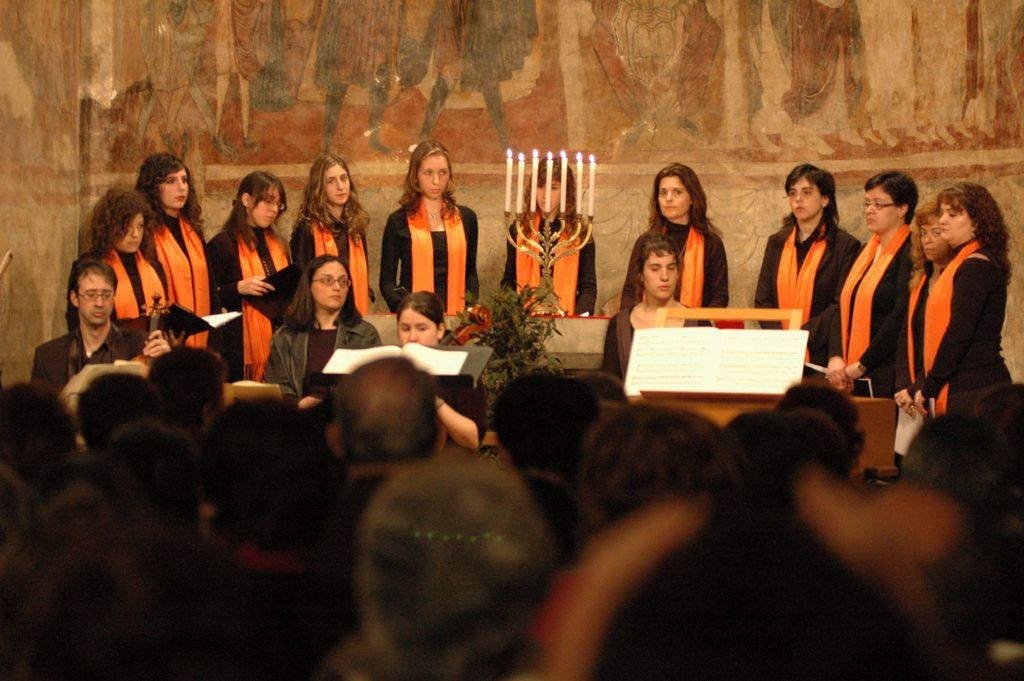What is happening in the center of the image? There is a group of people standing in the center of the image, along with a stand, candles, books, and a plant. Can you describe the stand in the center of the image? The stand is in the center of the image, and it is surrounded by the other items mentioned. What type of objects are present on the stand? Candles and books are present on the stand. What is the background of the image? There is a wall in the background of the image. How many crackers are being eaten by the people in the image? There is no mention of crackers in the image, so we cannot determine how many are being eaten. Is the scene in the image completely quiet? The image does not provide any information about the sound level, so we cannot determine if the scene is quiet or not. 